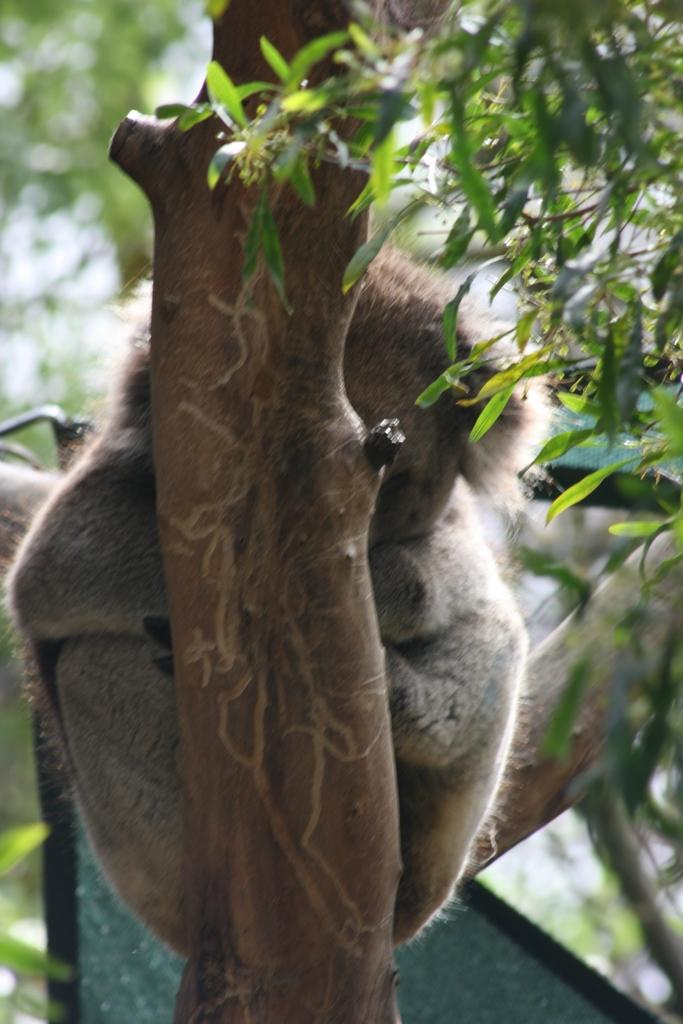Where was the picture taken? The picture was clicked outside. What can be seen in the foreground of the image? There is a tree and an animal in the foreground of the image. What type of vegetation is visible in the background of the image? There are green leaves in the background of the image. What else can be seen in the background of the image? There are other objects in the background of the image. What type of punishment is being given to the animal in the image? There is no indication of punishment in the image; it simply shows a tree and an animal in the foreground. 